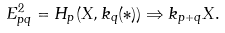<formula> <loc_0><loc_0><loc_500><loc_500>E ^ { 2 } _ { p q } = H _ { p } ( X , k _ { q } ( * ) ) \Rightarrow k _ { p + q } X .</formula> 